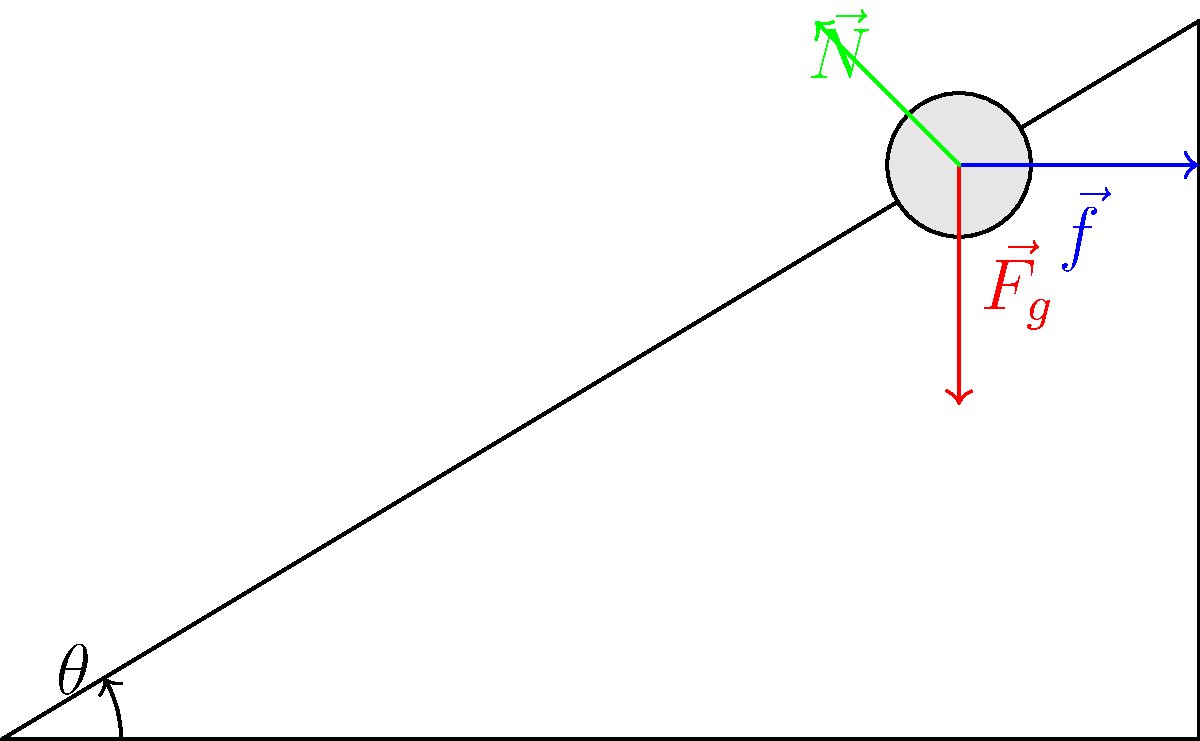In the context of social mobility studies, consider a block resting on an inclined plane at an angle $\theta$ to the horizontal. The block represents an individual's socioeconomic status, while the plane symbolizes the societal structure. If the coefficient of static friction is $\mu_s = 0.4$ and $\sin\theta = 0.6$, determine the minimum mass of the block that would prevent it from sliding down the plane. How might this relate to the challenges faced by immigrants in maintaining their social status? Let's approach this step-by-step, drawing parallels to social mobility:

1) First, identify the forces acting on the block:
   - Weight ($\vec{F_g}$) acting downward
   - Normal force ($\vec{N}$) perpendicular to the plane
   - Friction force ($\vec{f}$) parallel to the plane, opposing motion

2) The component of weight parallel to the plane is what causes the tendency to slide:
   $F_{\parallel} = mg\sin\theta$

3) The maximum static friction force is given by:
   $f_{max} = \mu_s N$

4) For the block to be on the verge of sliding, these forces must be equal:
   $mg\sin\theta = \mu_s N$

5) The normal force is related to the weight by:
   $N = mg\cos\theta$

6) Substituting this into the equation from step 4:
   $mg\sin\theta = \mu_s mg\cos\theta$

7) Simplify:
   $\tan\theta = \mu_s$

8) We're given $\sin\theta = 0.6$ and $\mu_s = 0.4$. We need to find $\cos\theta$:
   $\cos\theta = \sqrt{1 - \sin^2\theta} = \sqrt{1 - 0.6^2} = 0.8$

9) Now we can check if $\tan\theta > \mu_s$:
   $\tan\theta = \frac{\sin\theta}{\cos\theta} = \frac{0.6}{0.8} = 0.75$

   Since $0.75 > 0.4$, the block will slide regardless of its mass.

In the context of social mobility, this suggests that the "societal structure" (inclined plane) is too steep for the "individual" (block) to maintain their position, regardless of their "social capital" (mass). This could represent the challenges immigrants face in maintaining their social status in a new country, where structural barriers (steep incline) may outweigh personal resources (friction).
Answer: The block will slide regardless of its mass, as $\tan\theta (0.75) > \mu_s (0.4)$. 